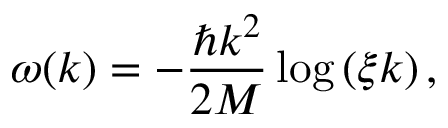Convert formula to latex. <formula><loc_0><loc_0><loc_500><loc_500>\omega ( k ) = - \frac { \hbar { k } ^ { 2 } } { 2 M } \log \left ( \xi k \right ) ,</formula> 